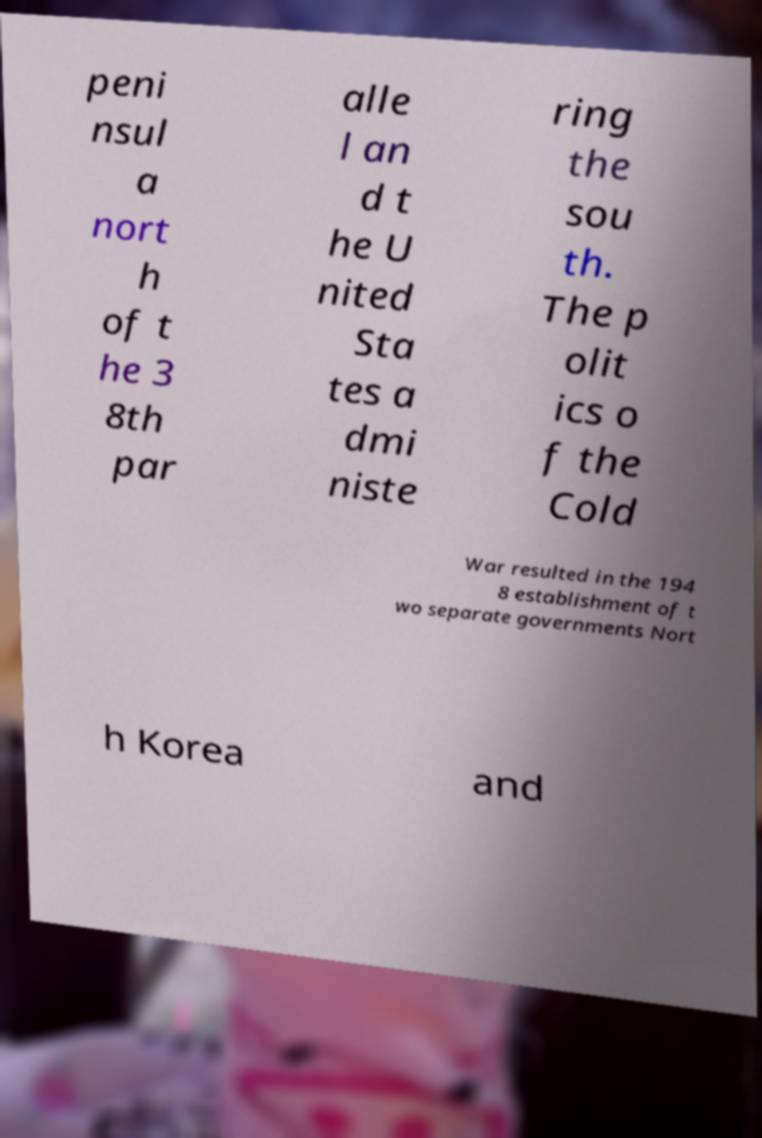What messages or text are displayed in this image? I need them in a readable, typed format. peni nsul a nort h of t he 3 8th par alle l an d t he U nited Sta tes a dmi niste ring the sou th. The p olit ics o f the Cold War resulted in the 194 8 establishment of t wo separate governments Nort h Korea and 